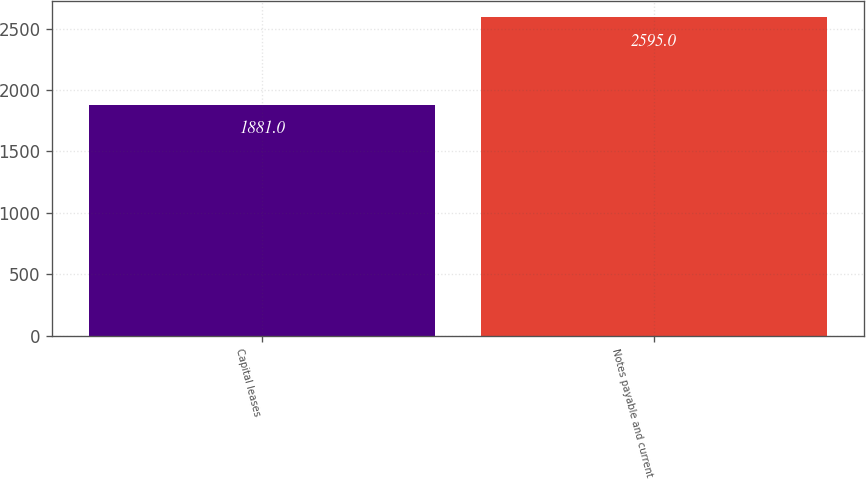Convert chart to OTSL. <chart><loc_0><loc_0><loc_500><loc_500><bar_chart><fcel>Capital leases<fcel>Notes payable and current<nl><fcel>1881<fcel>2595<nl></chart> 